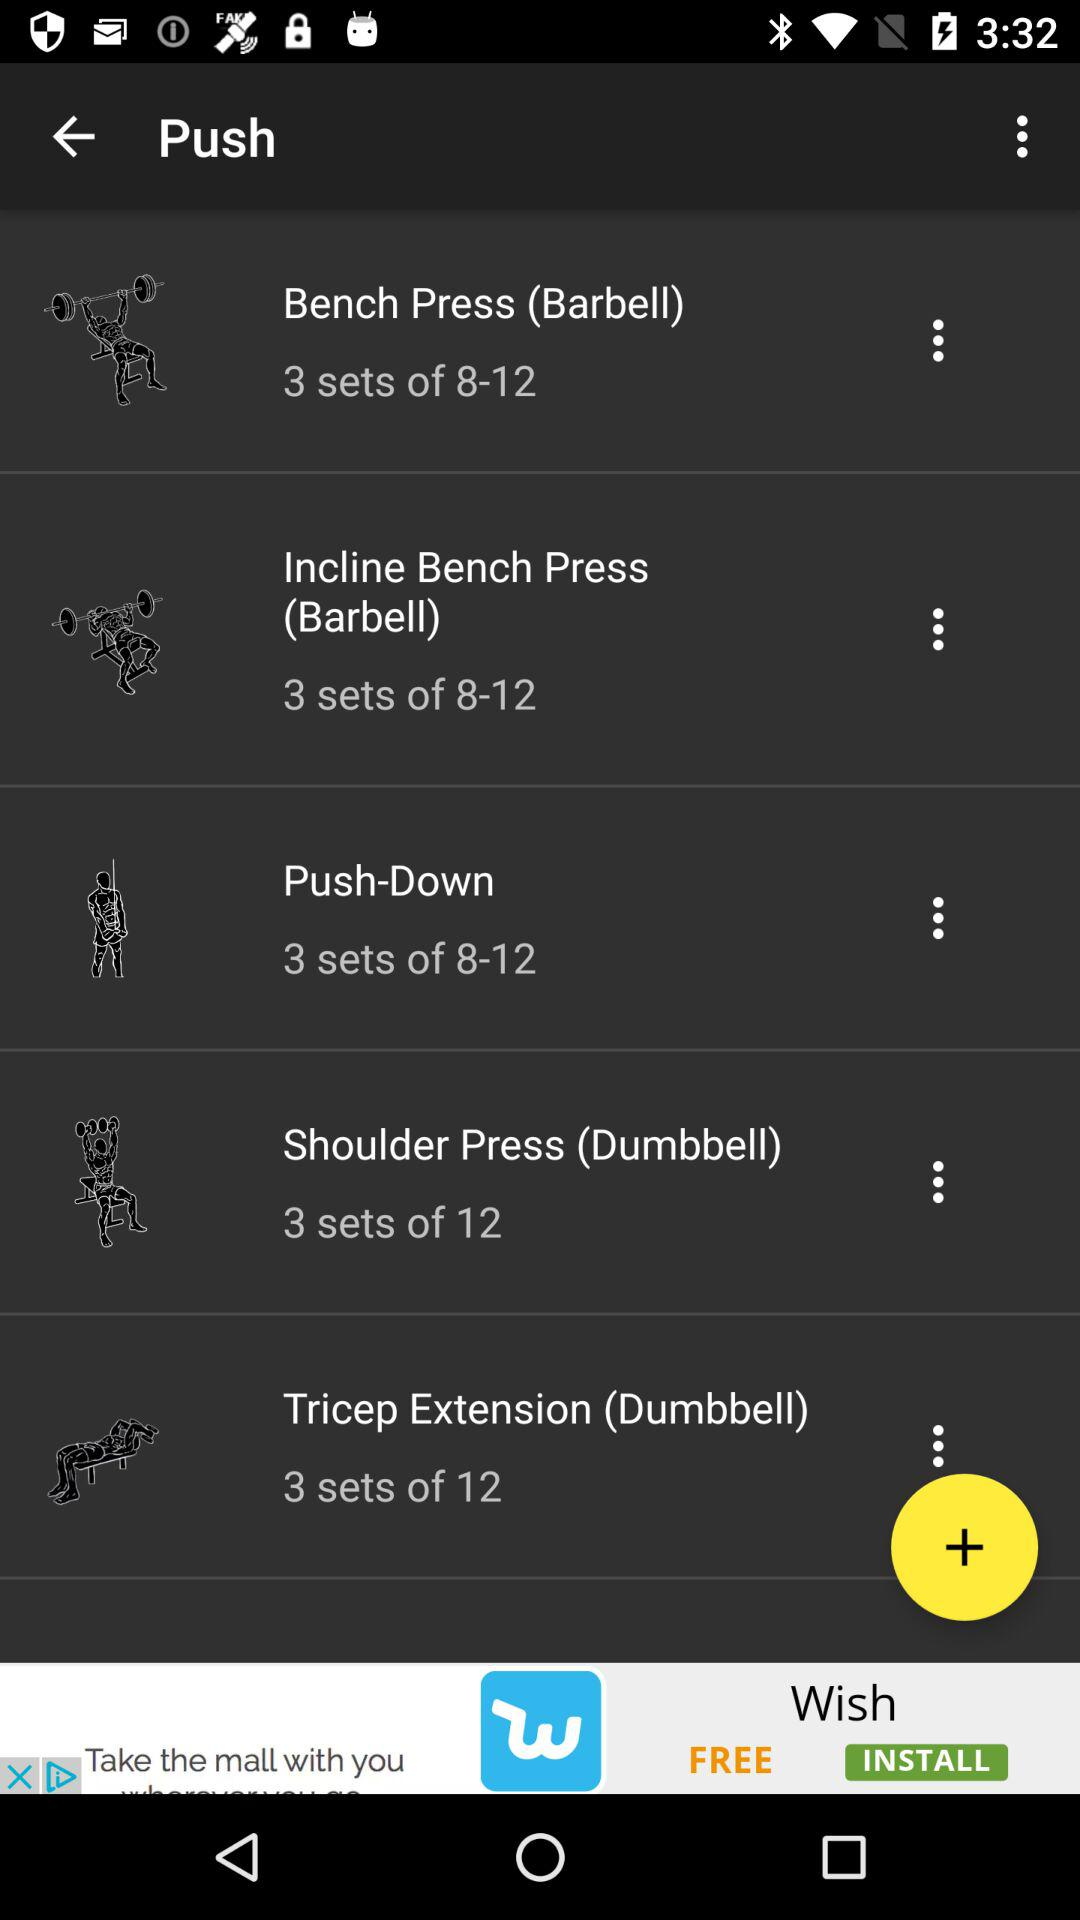How many sets of bench press (barbell) are there? There are 3 sets. 